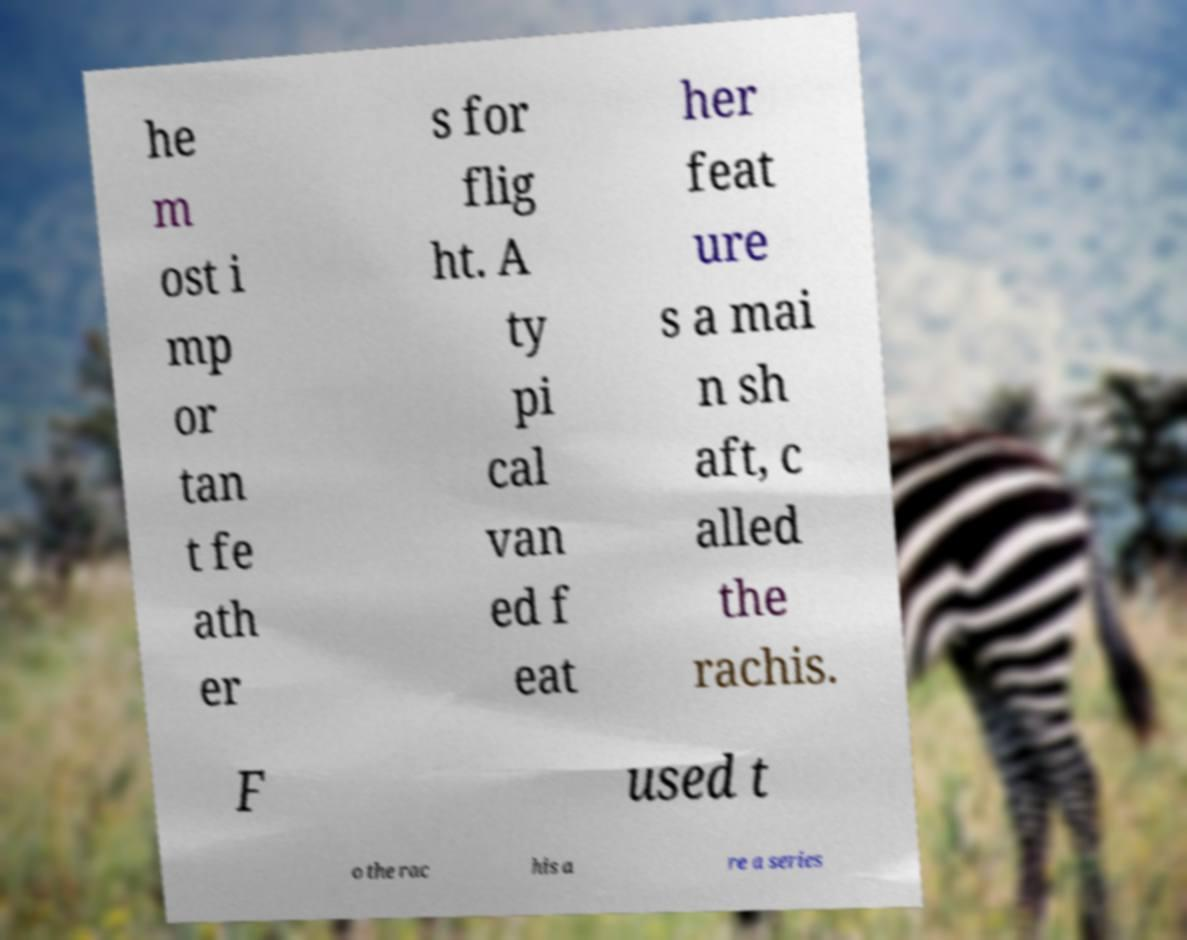Can you accurately transcribe the text from the provided image for me? he m ost i mp or tan t fe ath er s for flig ht. A ty pi cal van ed f eat her feat ure s a mai n sh aft, c alled the rachis. F used t o the rac his a re a series 